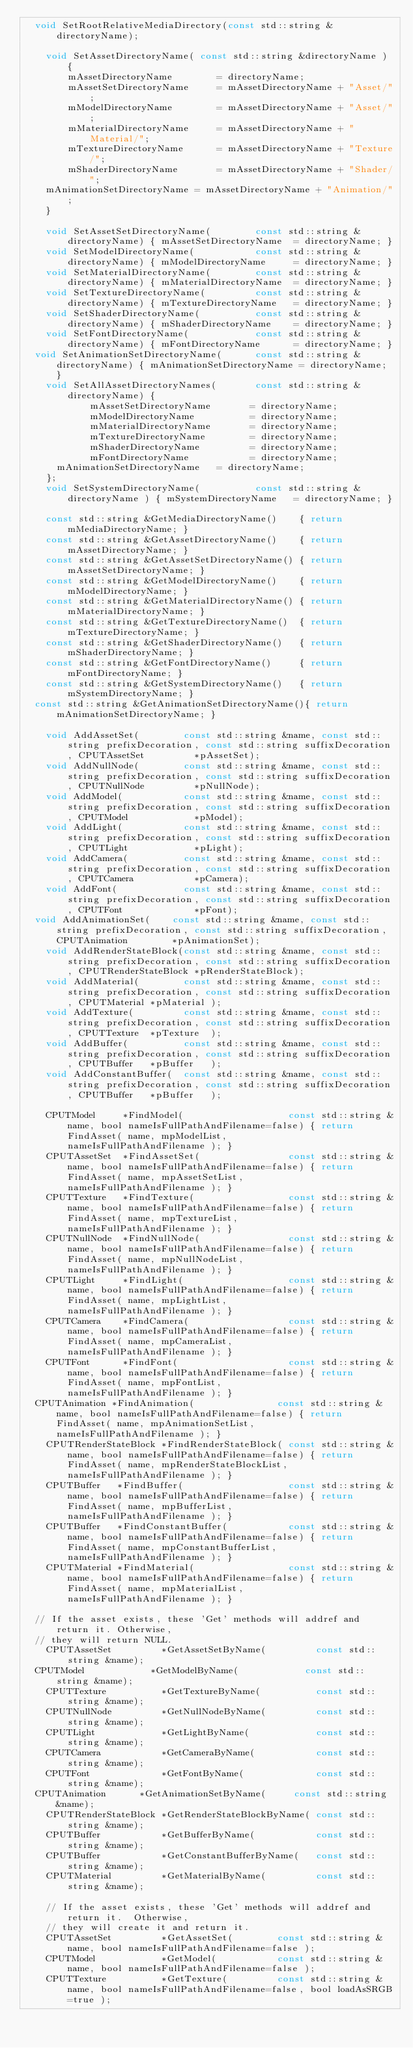Convert code to text. <code><loc_0><loc_0><loc_500><loc_500><_C_>	void SetRootRelativeMediaDirectory(const std::string &directoryName);

    void SetAssetDirectoryName( const std::string &directoryName ) {
        mAssetDirectoryName        = directoryName;
        mAssetSetDirectoryName     = mAssetDirectoryName + "Asset/";
        mModelDirectoryName        = mAssetDirectoryName + "Asset/";
        mMaterialDirectoryName     = mAssetDirectoryName + "Material/";
        mTextureDirectoryName      = mAssetDirectoryName + "Texture/";
        mShaderDirectoryName       = mAssetDirectoryName + "Shader/";
		mAnimationSetDirectoryName = mAssetDirectoryName + "Animation/";
    }

    void SetAssetSetDirectoryName(        const std::string &directoryName) { mAssetSetDirectoryName  = directoryName; }
    void SetModelDirectoryName(           const std::string &directoryName) { mModelDirectoryName     = directoryName; }
    void SetMaterialDirectoryName(        const std::string &directoryName) { mMaterialDirectoryName  = directoryName; }
    void SetTextureDirectoryName(         const std::string &directoryName) { mTextureDirectoryName   = directoryName; }
    void SetShaderDirectoryName(          const std::string &directoryName) { mShaderDirectoryName    = directoryName; }
    void SetFontDirectoryName(            const std::string &directoryName) { mFontDirectoryName      = directoryName; }
	void SetAnimationSetDirectoryName(      const std::string &directoryName) { mAnimationSetDirectoryName = directoryName; }
    void SetAllAssetDirectoryNames(       const std::string &directoryName) {
            mAssetSetDirectoryName       = directoryName;
            mModelDirectoryName          = directoryName;
            mMaterialDirectoryName       = directoryName;
            mTextureDirectoryName        = directoryName;
            mShaderDirectoryName         = directoryName;
            mFontDirectoryName           = directoryName;
			mAnimationSetDirectoryName	 = directoryName;
    };
    void SetSystemDirectoryName(          const std::string &directoryName ) { mSystemDirectoryName   = directoryName; }

    const std::string &GetMediaDirectoryName()    { return mMediaDirectoryName; }
    const std::string &GetAssetDirectoryName()    { return mAssetDirectoryName; }
    const std::string &GetAssetSetDirectoryName() { return mAssetSetDirectoryName; }
    const std::string &GetModelDirectoryName()    { return mModelDirectoryName; }
    const std::string &GetMaterialDirectoryName() { return mMaterialDirectoryName; }
    const std::string &GetTextureDirectoryName()  { return mTextureDirectoryName; }
    const std::string &GetShaderDirectoryName()   { return mShaderDirectoryName; }
    const std::string &GetFontDirectoryName()     { return mFontDirectoryName; }
    const std::string &GetSystemDirectoryName()   { return mSystemDirectoryName; }
	const std::string &GetAnimationSetDirectoryName(){ return mAnimationSetDirectoryName; }

    void AddAssetSet(        const std::string &name, const std::string prefixDecoration, const std::string suffixDecoration, CPUTAssetSet         *pAssetSet);
    void AddNullNode(        const std::string &name, const std::string prefixDecoration, const std::string suffixDecoration, CPUTNullNode         *pNullNode);
    void AddModel(           const std::string &name, const std::string prefixDecoration, const std::string suffixDecoration, CPUTModel            *pModel);
    void AddLight(           const std::string &name, const std::string prefixDecoration, const std::string suffixDecoration, CPUTLight            *pLight);
    void AddCamera(          const std::string &name, const std::string prefixDecoration, const std::string suffixDecoration, CPUTCamera           *pCamera);
    void AddFont(            const std::string &name, const std::string prefixDecoration, const std::string suffixDecoration, CPUTFont             *pFont);
	void AddAnimationSet(    const std::string &name, const std::string prefixDecoration, const std::string suffixDecoration, CPUTAnimation	       *pAnimationSet);
    void AddRenderStateBlock(const std::string &name, const std::string prefixDecoration, const std::string suffixDecoration, CPUTRenderStateBlock *pRenderStateBlock);
    void AddMaterial(        const std::string &name, const std::string prefixDecoration, const std::string suffixDecoration, CPUTMaterial *pMaterial );
    void AddTexture(         const std::string &name, const std::string prefixDecoration, const std::string suffixDecoration, CPUTTexture  *pTexture  );
    void AddBuffer(          const std::string &name, const std::string prefixDecoration, const std::string suffixDecoration, CPUTBuffer   *pBuffer   );
    void AddConstantBuffer(  const std::string &name, const std::string prefixDecoration, const std::string suffixDecoration, CPUTBuffer   *pBuffer   );

    CPUTModel     *FindModel(                   const std::string &name, bool nameIsFullPathAndFilename=false) { return FindAsset( name, mpModelList,            nameIsFullPathAndFilename ); }
    CPUTAssetSet  *FindAssetSet(                const std::string &name, bool nameIsFullPathAndFilename=false) { return FindAsset( name, mpAssetSetList,         nameIsFullPathAndFilename ); }
    CPUTTexture   *FindTexture(                 const std::string &name, bool nameIsFullPathAndFilename=false) { return FindAsset( name, mpTextureList,          nameIsFullPathAndFilename ); }
    CPUTNullNode  *FindNullNode(                const std::string &name, bool nameIsFullPathAndFilename=false) { return FindAsset( name, mpNullNodeList,         nameIsFullPathAndFilename ); }
    CPUTLight     *FindLight(                   const std::string &name, bool nameIsFullPathAndFilename=false) { return FindAsset( name, mpLightList,            nameIsFullPathAndFilename ); }
    CPUTCamera    *FindCamera(                  const std::string &name, bool nameIsFullPathAndFilename=false) { return FindAsset( name, mpCameraList,           nameIsFullPathAndFilename ); }
    CPUTFont      *FindFont(                    const std::string &name, bool nameIsFullPathAndFilename=false) { return FindAsset( name, mpFontList,             nameIsFullPathAndFilename ); }
	CPUTAnimation *FindAnimation(               const std::string &name, bool nameIsFullPathAndFilename=false) { return FindAsset( name, mpAnimationSetList,     nameIsFullPathAndFilename ); }
    CPUTRenderStateBlock *FindRenderStateBlock( const std::string &name, bool nameIsFullPathAndFilename=false) { return FindAsset( name, mpRenderStateBlockList, nameIsFullPathAndFilename ); }
    CPUTBuffer   *FindBuffer(                   const std::string &name, bool nameIsFullPathAndFilename=false) { return FindAsset( name, mpBufferList,           nameIsFullPathAndFilename ); }
    CPUTBuffer   *FindConstantBuffer(           const std::string &name, bool nameIsFullPathAndFilename=false) { return FindAsset( name, mpConstantBufferList,   nameIsFullPathAndFilename ); }
    CPUTMaterial *FindMaterial(                 const std::string &name, bool nameIsFullPathAndFilename=false) { return FindAsset( name, mpMaterialList,         nameIsFullPathAndFilename ); }
    
	// If the asset exists, these 'Get' methods will addref and return it. Otherwise,
	// they will return NULL.
    CPUTAssetSet         *GetAssetSetByName(         const std::string &name);
	CPUTModel            *GetModelByName(            const std::string &name);
    CPUTTexture          *GetTextureByName(          const std::string &name);
    CPUTNullNode         *GetNullNodeByName(         const std::string &name);
    CPUTLight            *GetLightByName(            const std::string &name);
    CPUTCamera           *GetCameraByName(           const std::string &name);
    CPUTFont             *GetFontByName(             const std::string &name);
	CPUTAnimation	     *GetAnimationSetByName(     const std::string &name);
    CPUTRenderStateBlock *GetRenderStateBlockByName( const std::string &name);
    CPUTBuffer           *GetBufferByName(           const std::string &name);
    CPUTBuffer           *GetConstantBufferByName(   const std::string &name);
    CPUTMaterial         *GetMaterialByName(         const std::string &name);

    // If the asset exists, these 'Get' methods will addref and return it.  Otherwise,
    // they will create it and return it.
    CPUTAssetSet         *GetAssetSet(        const std::string &name, bool nameIsFullPathAndFilename=false );
    CPUTModel            *GetModel(           const std::string &name, bool nameIsFullPathAndFilename=false );
    CPUTTexture          *GetTexture(         const std::string &name, bool nameIsFullPathAndFilename=false, bool loadAsSRGB=true );</code> 